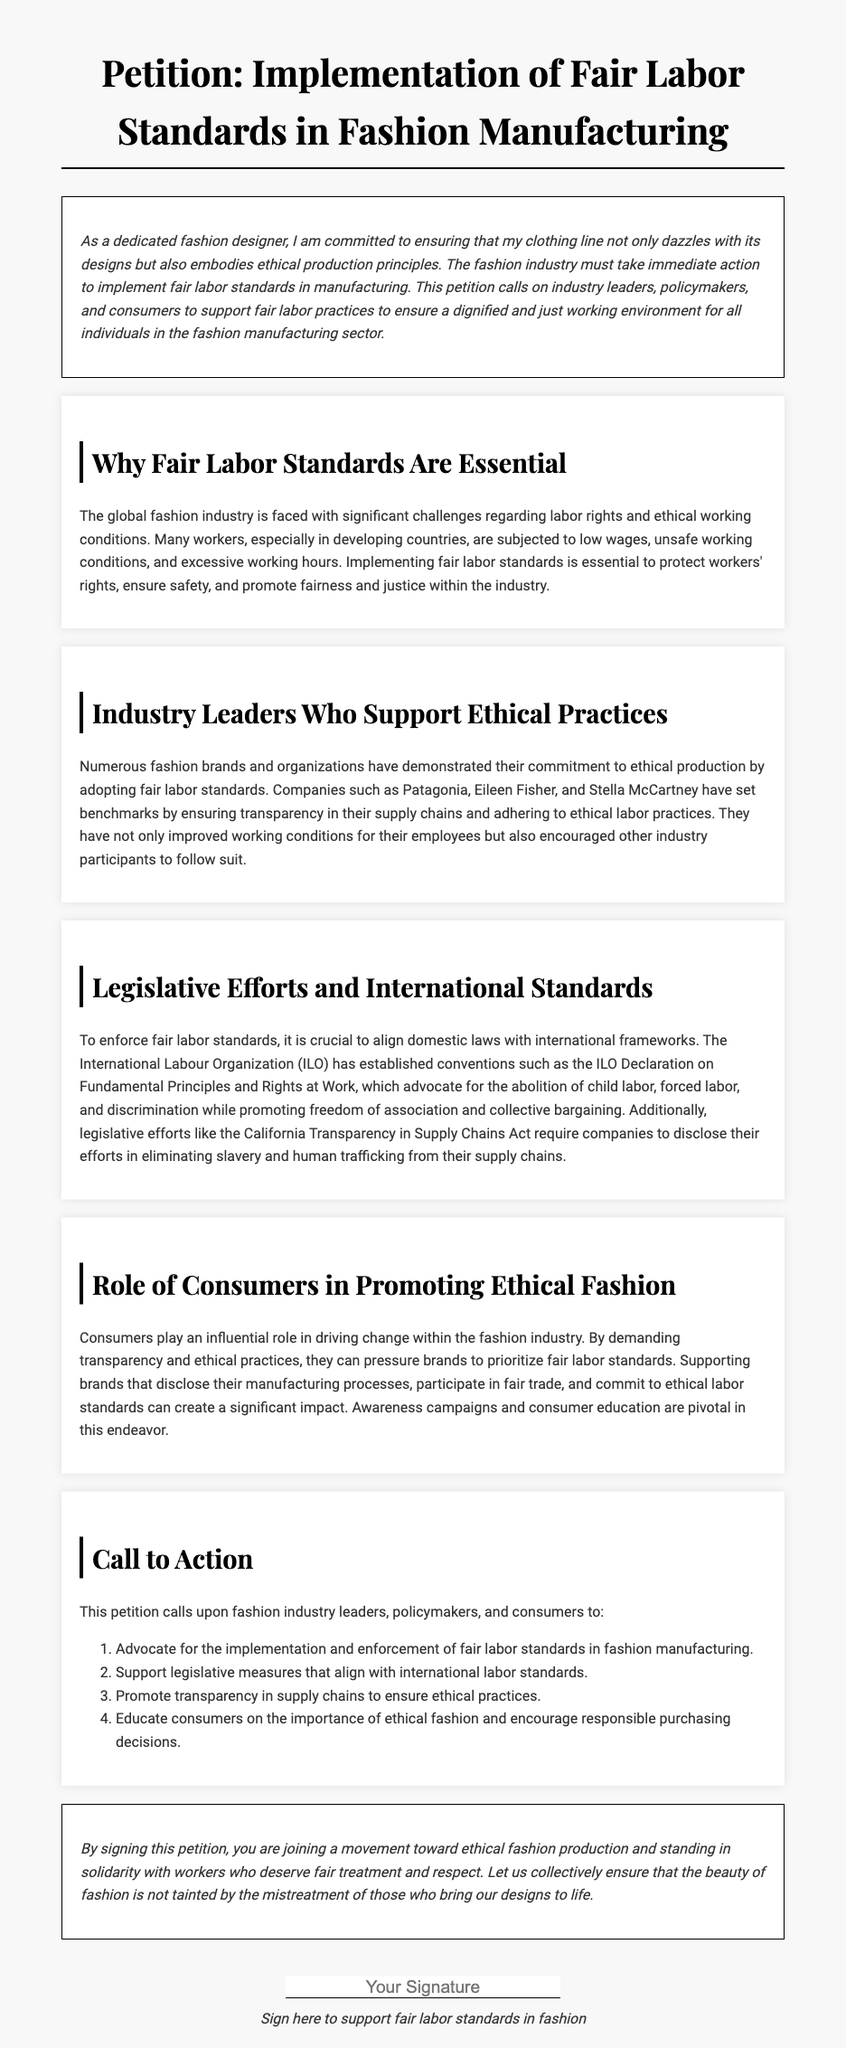What is the title of the petition? The title appears prominently at the top of the document, indicating the primary focus of the petition.
Answer: Implementation of Fair Labor Standards in Fashion Manufacturing Who are two fashion brands mentioned that support ethical practices? The document lists examples of brands that embody ethical production, highlighting their commitment to fair labor.
Answer: Patagonia, Eileen Fisher What document is referenced as setting international labor standards? The document discusses international frameworks that promote labor rights, consolidating these standards through formal declarations.
Answer: ILO Declaration on Fundamental Principles and Rights at Work What is the main call to action for industry leaders? A specific advocacy point outlined as a significant action item for industry stakeholders, guiding their role in fashion.
Answer: Advocate for the implementation and enforcement of fair labor standards in fashion manufacturing What type of campaign is important for consumer education? The text emphasizes a strategy directed at informing consumers about ethical consumption, driving awareness to prompt changes in the industry.
Answer: Awareness campaigns 